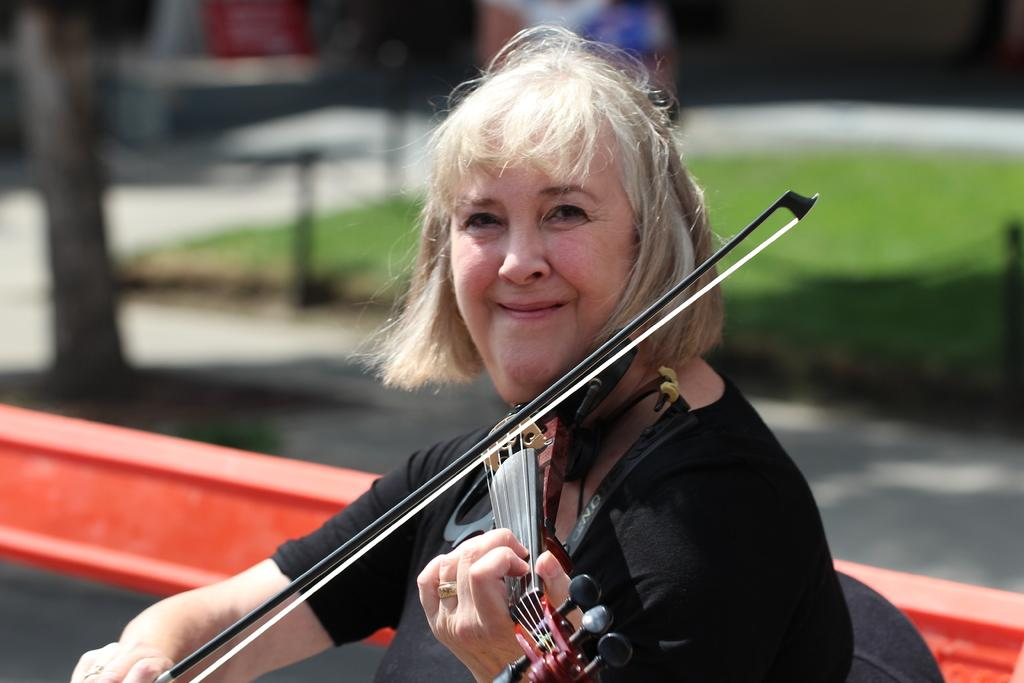Who is the main subject in the image? There is a woman in the image. What is the woman doing in the image? The woman is playing a guitar. What can be seen in the background of the image? There is a road and grass visible in the image. What type of peace symbol can be seen in the image? There is no peace symbol present in the image. How does the guitar burst into flames in the image? The guitar does not burst into flames in the image; it is being played by the woman. 